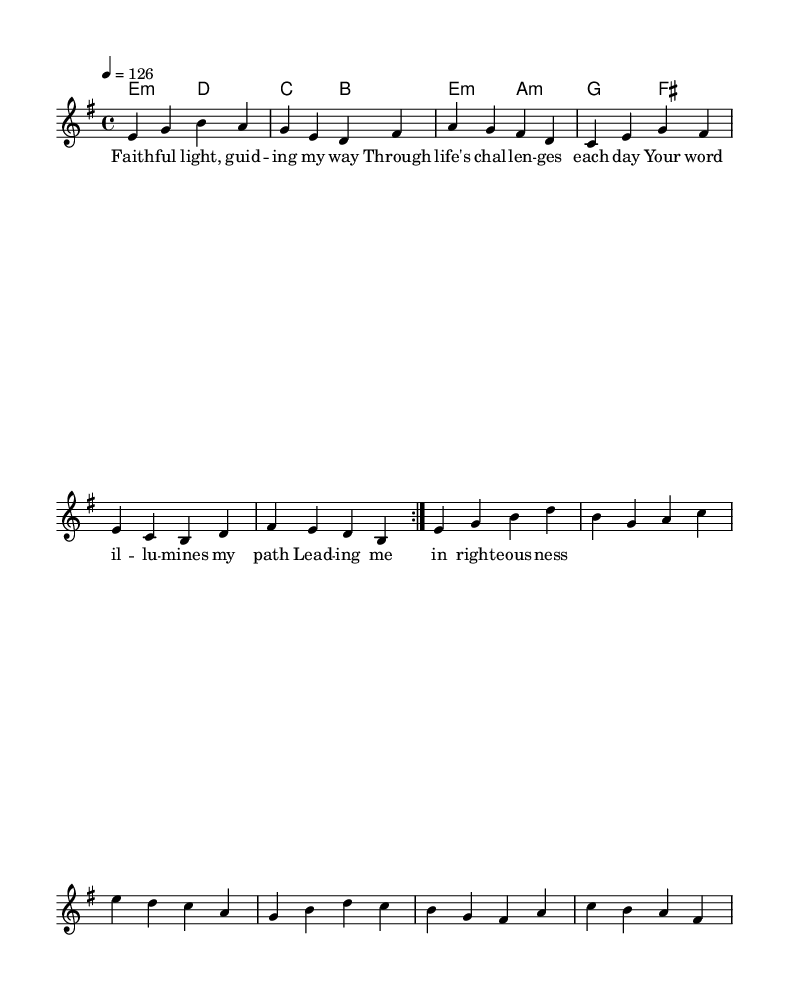What is the key signature of this music? The key signature is E minor, which contains one sharp (F#). The information comes from the section of the code where 'global' is defined with the key of E minor.
Answer: E minor What is the time signature of this piece? The time signature is 4/4, indicating four beats per measure. This information is found in the 'global' section where the time is defined as 4/4.
Answer: 4/4 What is the tempo marking for this composition? The tempo marking is a quarter note equals 126 beats per minute. This is explicitly stated in the 'global' section of the code.
Answer: 126 How many times is the main melody repeated? The main melody section is repeated two times, as indicated by the 'repeat volta 2' command in the melody's code.
Answer: 2 What are the first two words of the lyrics? The first two words of the lyrics are "Faith ful". This can be found in the 'verseWords' variable, where the lyrics start.
Answer: Faith ful What type of chords are used in the harmonies? The harmonies consist of minor chords, as indicated by the 'm' notation in the chord mode section. This signifies that all chords listed are indeed minor.
Answer: minor chords What biblical theme is suggested by the lyrics of this song? The lyrics suggest themes of guidance and righteousness, as they discuss leading in the right path, which aligns with biblical narratives of divine guidance.
Answer: guidance 